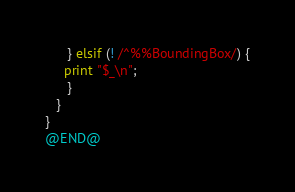Convert code to text. <code><loc_0><loc_0><loc_500><loc_500><_Perl_>      } elsif (! /^%%BoundingBox/) {
	 print "$_\n";
      }
   }
}
@END@
</code> 